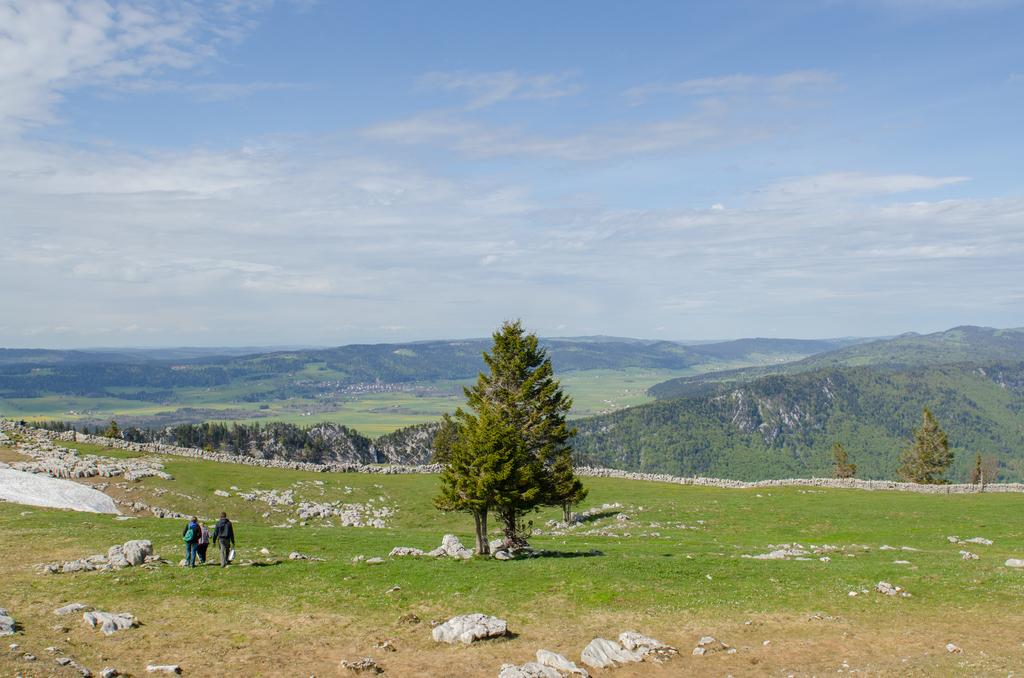What is located in the center of the image? There are trees in the center of the image. What can be seen on the left side of the image? There are people on the left side of the image. What type of natural features are visible in the background of the image? There are rocks and hills visible in the background of the image. What is visible above the trees and people in the image? The sky is visible in the image. What type of celery is being used to create a sculpture in the image? There is no celery present in the image; it features trees, people, rocks, hills, and the sky. How many balls are visible in the image? There are no balls visible in the image. 